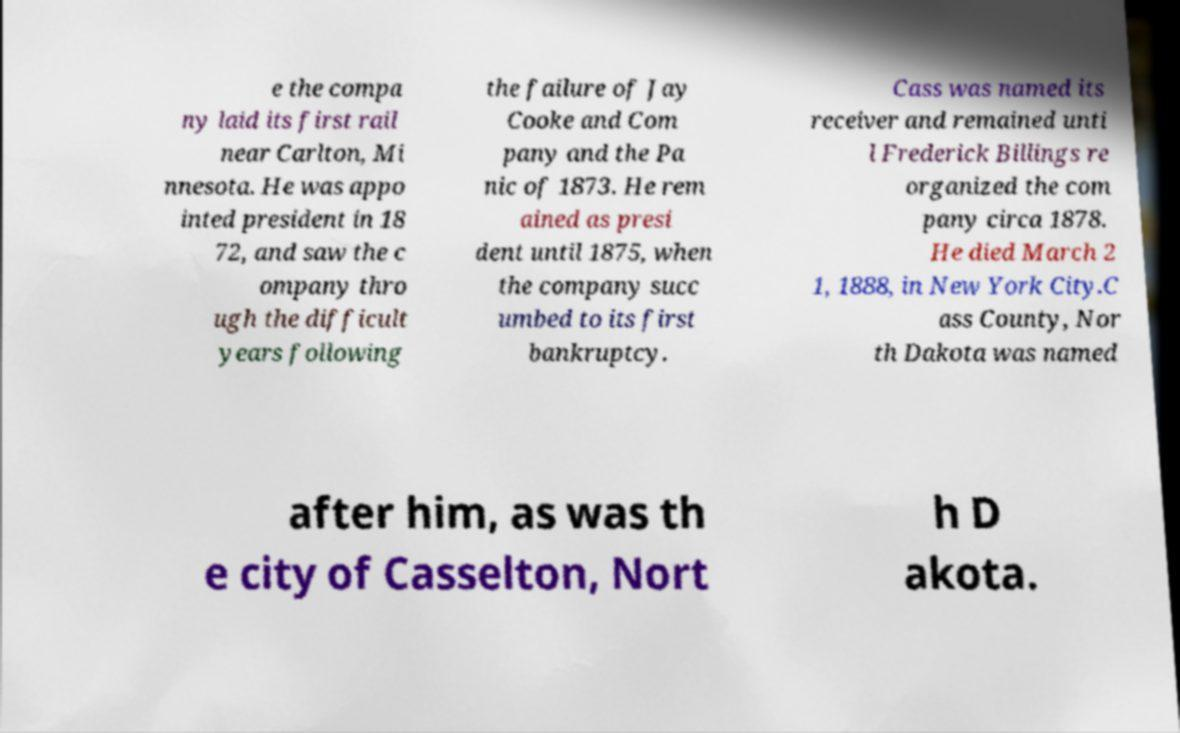Could you assist in decoding the text presented in this image and type it out clearly? e the compa ny laid its first rail near Carlton, Mi nnesota. He was appo inted president in 18 72, and saw the c ompany thro ugh the difficult years following the failure of Jay Cooke and Com pany and the Pa nic of 1873. He rem ained as presi dent until 1875, when the company succ umbed to its first bankruptcy. Cass was named its receiver and remained unti l Frederick Billings re organized the com pany circa 1878. He died March 2 1, 1888, in New York City.C ass County, Nor th Dakota was named after him, as was th e city of Casselton, Nort h D akota. 